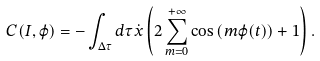Convert formula to latex. <formula><loc_0><loc_0><loc_500><loc_500>C ( I , \varphi ) = - \int _ { \Delta \tau } d \tau \dot { x } \left ( 2 \sum _ { m = 0 } ^ { + \infty } \cos { ( m \varphi ( t ) ) } + 1 \right ) .</formula> 